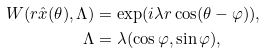<formula> <loc_0><loc_0><loc_500><loc_500>W ( r \hat { x } ( \theta ) , \Lambda ) & = \exp ( i \lambda r \cos ( \theta - \varphi ) ) , \\ \Lambda & = \lambda ( \cos \varphi , \sin \varphi ) ,</formula> 